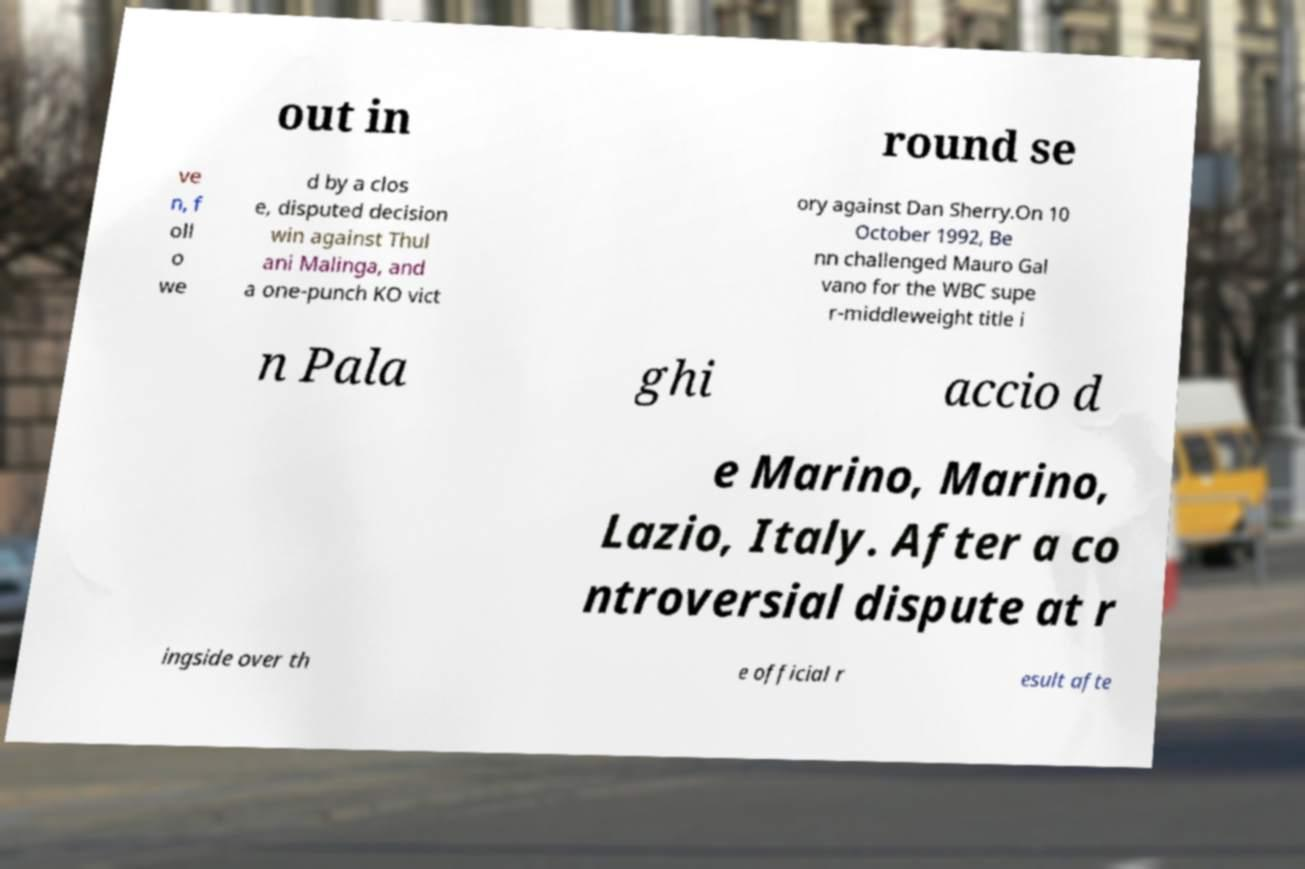Can you accurately transcribe the text from the provided image for me? out in round se ve n, f oll o we d by a clos e, disputed decision win against Thul ani Malinga, and a one-punch KO vict ory against Dan Sherry.On 10 October 1992, Be nn challenged Mauro Gal vano for the WBC supe r-middleweight title i n Pala ghi accio d e Marino, Marino, Lazio, Italy. After a co ntroversial dispute at r ingside over th e official r esult afte 